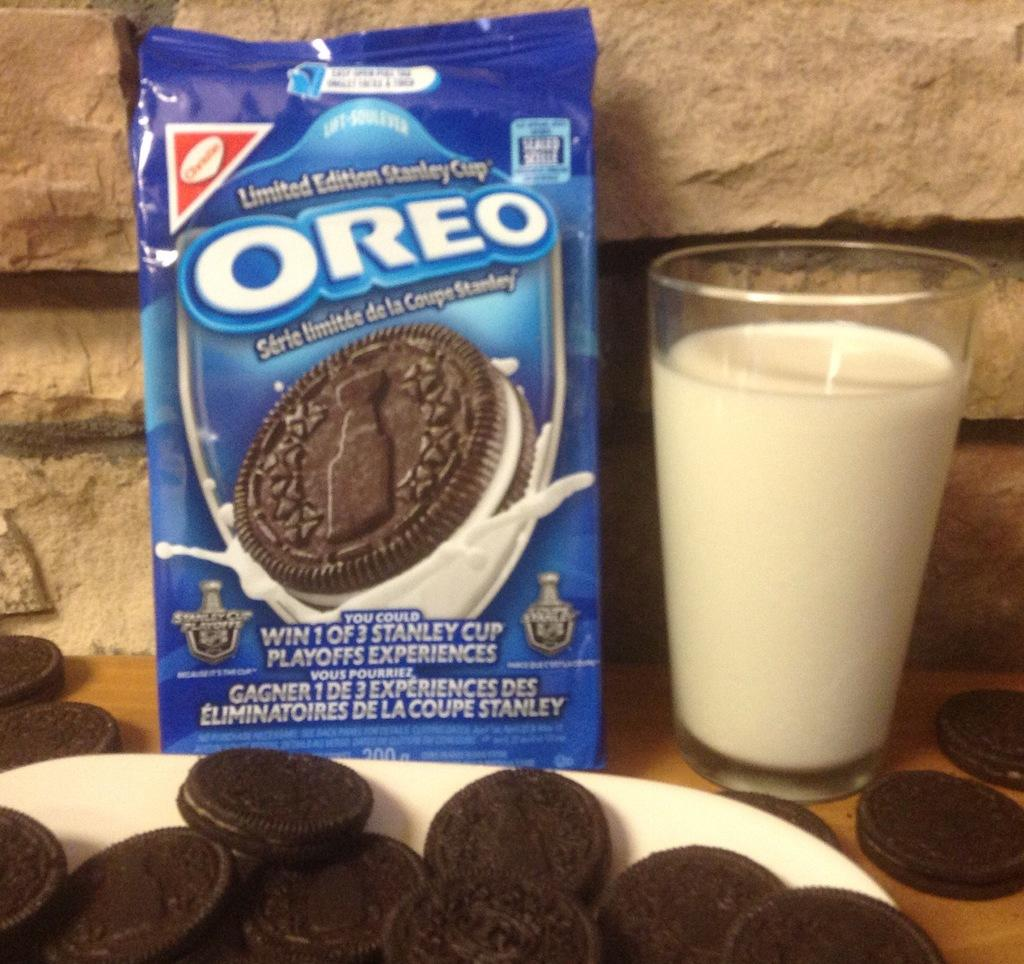What type of furniture is present in the image? There is a table in the image. What is contained in the glass on the table? The glass contains milk. What is placed on the plate in the image? There are biscuits on the plate. Where can you find the biscuit carton in the image? The biscuit carton is also present in the image. What is visible in the background of the image? There is a wall in the background of the image. What type of orange can be seen in the image? There is no orange present in the image. Is there a cannon visible in the image? No, there is no cannon present in the image. Can you see a train in the image? No, there is no train present in the image. 